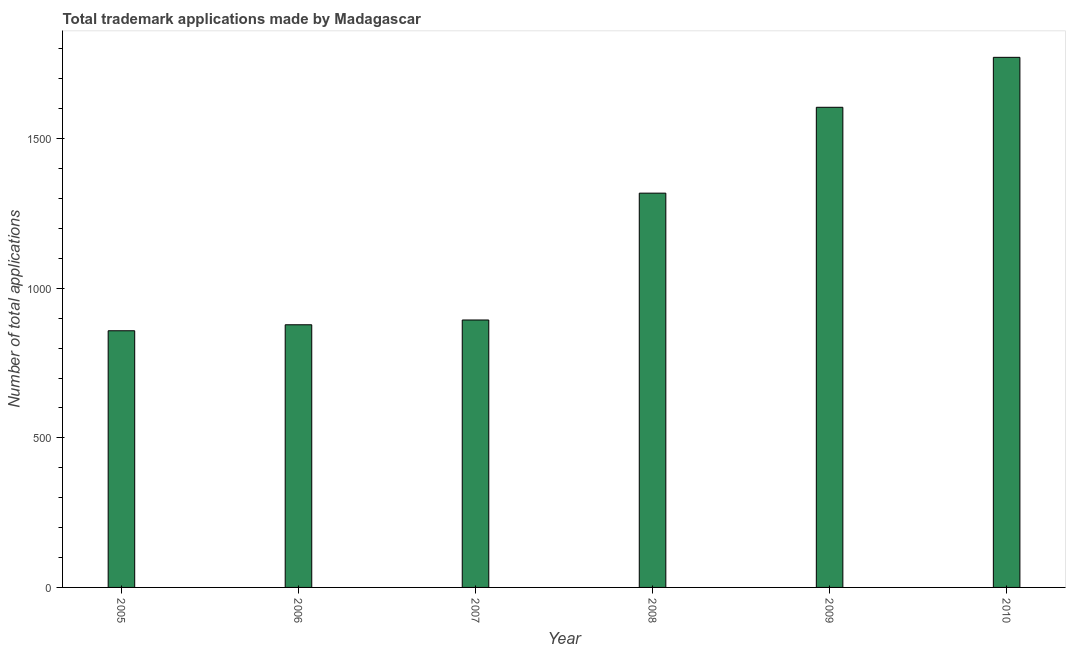Does the graph contain grids?
Your response must be concise. No. What is the title of the graph?
Your answer should be very brief. Total trademark applications made by Madagascar. What is the label or title of the Y-axis?
Your answer should be compact. Number of total applications. What is the number of trademark applications in 2010?
Keep it short and to the point. 1772. Across all years, what is the maximum number of trademark applications?
Your answer should be compact. 1772. Across all years, what is the minimum number of trademark applications?
Your answer should be very brief. 858. In which year was the number of trademark applications minimum?
Your answer should be very brief. 2005. What is the sum of the number of trademark applications?
Ensure brevity in your answer.  7325. What is the difference between the number of trademark applications in 2007 and 2010?
Give a very brief answer. -878. What is the average number of trademark applications per year?
Offer a very short reply. 1220. What is the median number of trademark applications?
Your answer should be very brief. 1106. What is the ratio of the number of trademark applications in 2008 to that in 2009?
Keep it short and to the point. 0.82. Is the number of trademark applications in 2008 less than that in 2009?
Your answer should be very brief. Yes. Is the difference between the number of trademark applications in 2005 and 2010 greater than the difference between any two years?
Offer a very short reply. Yes. What is the difference between the highest and the second highest number of trademark applications?
Give a very brief answer. 167. What is the difference between the highest and the lowest number of trademark applications?
Ensure brevity in your answer.  914. How many bars are there?
Your answer should be very brief. 6. Are all the bars in the graph horizontal?
Give a very brief answer. No. How many years are there in the graph?
Your answer should be very brief. 6. What is the difference between two consecutive major ticks on the Y-axis?
Provide a succinct answer. 500. Are the values on the major ticks of Y-axis written in scientific E-notation?
Your answer should be compact. No. What is the Number of total applications of 2005?
Make the answer very short. 858. What is the Number of total applications in 2006?
Provide a succinct answer. 878. What is the Number of total applications in 2007?
Offer a terse response. 894. What is the Number of total applications in 2008?
Give a very brief answer. 1318. What is the Number of total applications of 2009?
Offer a terse response. 1605. What is the Number of total applications of 2010?
Your response must be concise. 1772. What is the difference between the Number of total applications in 2005 and 2007?
Provide a succinct answer. -36. What is the difference between the Number of total applications in 2005 and 2008?
Your answer should be compact. -460. What is the difference between the Number of total applications in 2005 and 2009?
Your response must be concise. -747. What is the difference between the Number of total applications in 2005 and 2010?
Your answer should be very brief. -914. What is the difference between the Number of total applications in 2006 and 2008?
Provide a succinct answer. -440. What is the difference between the Number of total applications in 2006 and 2009?
Offer a very short reply. -727. What is the difference between the Number of total applications in 2006 and 2010?
Keep it short and to the point. -894. What is the difference between the Number of total applications in 2007 and 2008?
Your answer should be very brief. -424. What is the difference between the Number of total applications in 2007 and 2009?
Your response must be concise. -711. What is the difference between the Number of total applications in 2007 and 2010?
Make the answer very short. -878. What is the difference between the Number of total applications in 2008 and 2009?
Offer a terse response. -287. What is the difference between the Number of total applications in 2008 and 2010?
Give a very brief answer. -454. What is the difference between the Number of total applications in 2009 and 2010?
Offer a very short reply. -167. What is the ratio of the Number of total applications in 2005 to that in 2008?
Offer a terse response. 0.65. What is the ratio of the Number of total applications in 2005 to that in 2009?
Keep it short and to the point. 0.54. What is the ratio of the Number of total applications in 2005 to that in 2010?
Offer a terse response. 0.48. What is the ratio of the Number of total applications in 2006 to that in 2007?
Keep it short and to the point. 0.98. What is the ratio of the Number of total applications in 2006 to that in 2008?
Give a very brief answer. 0.67. What is the ratio of the Number of total applications in 2006 to that in 2009?
Provide a succinct answer. 0.55. What is the ratio of the Number of total applications in 2006 to that in 2010?
Your answer should be very brief. 0.49. What is the ratio of the Number of total applications in 2007 to that in 2008?
Ensure brevity in your answer.  0.68. What is the ratio of the Number of total applications in 2007 to that in 2009?
Offer a terse response. 0.56. What is the ratio of the Number of total applications in 2007 to that in 2010?
Your answer should be very brief. 0.51. What is the ratio of the Number of total applications in 2008 to that in 2009?
Your answer should be compact. 0.82. What is the ratio of the Number of total applications in 2008 to that in 2010?
Your answer should be compact. 0.74. What is the ratio of the Number of total applications in 2009 to that in 2010?
Offer a very short reply. 0.91. 